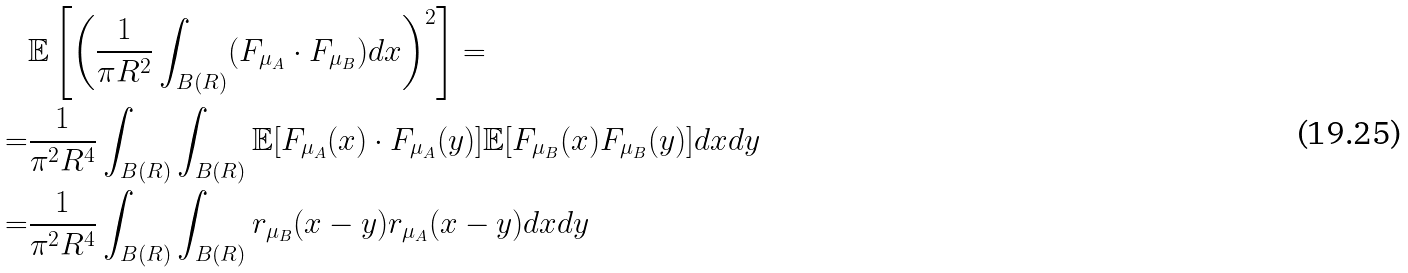<formula> <loc_0><loc_0><loc_500><loc_500>& \mathbb { E } \left [ \left ( \frac { 1 } { \pi R ^ { 2 } } \int _ { B ( R ) } ( F _ { \mu _ { A } } \cdot F _ { \mu _ { B } } ) d x \right ) ^ { 2 } \right ] = \\ = & \frac { 1 } { \pi ^ { 2 } R ^ { 4 } } \int _ { B ( R ) } \int _ { B ( R ) } \mathbb { E } [ F _ { \mu _ { A } } ( x ) \cdot F _ { \mu _ { A } } ( y ) ] \mathbb { E } [ F _ { \mu _ { B } } ( x ) F _ { \mu _ { B } } ( y ) ] d x d y \\ = & \frac { 1 } { \pi ^ { 2 } R ^ { 4 } } \int _ { B ( R ) } \int _ { B ( R ) } r _ { \mu _ { B } } ( x - y ) r _ { \mu _ { A } } ( x - y ) d x d y</formula> 